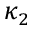Convert formula to latex. <formula><loc_0><loc_0><loc_500><loc_500>\kappa _ { 2 }</formula> 